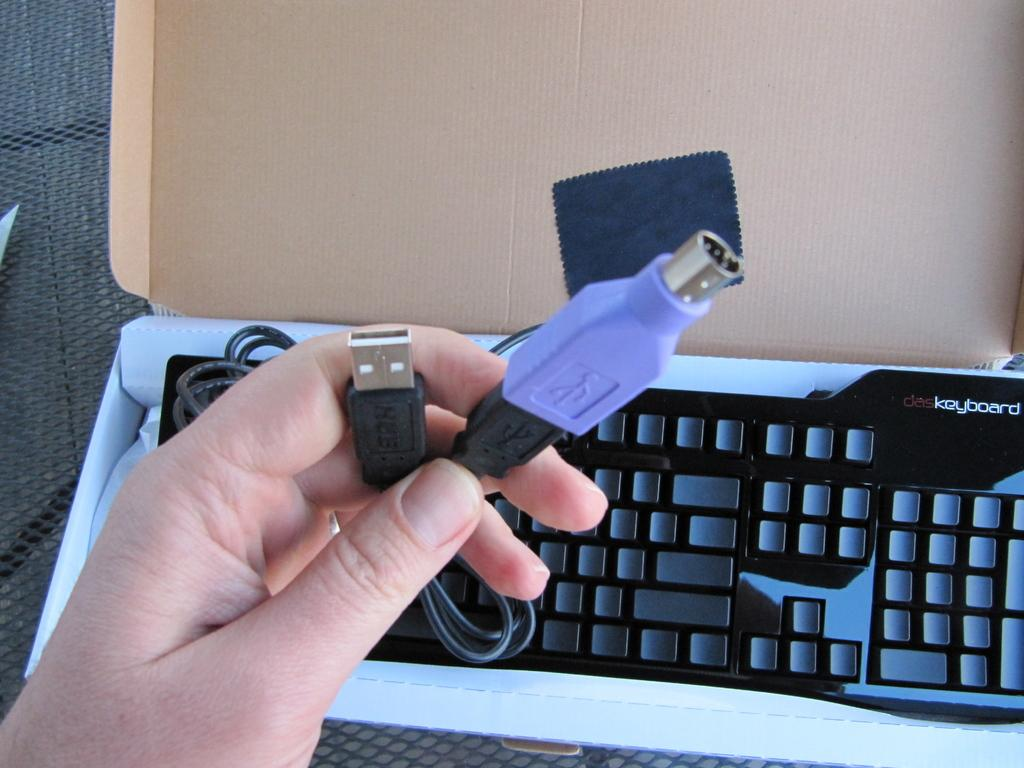<image>
Give a short and clear explanation of the subsequent image. A hand unpacks cords from a box that contains a dasKeyboard. 